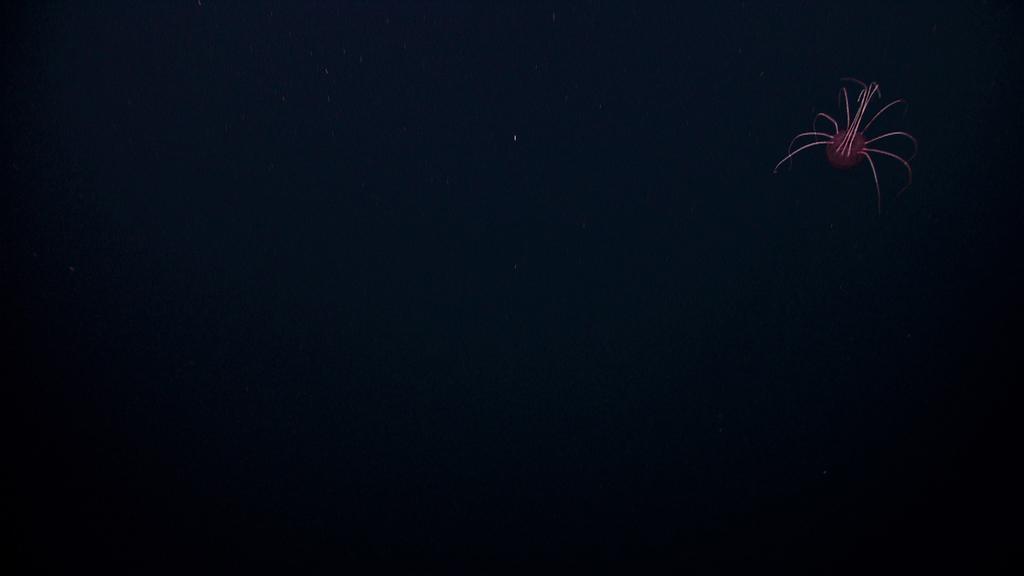Please provide a concise description of this image. In this image, on the right side, we can see a light. In the background, we can see black color. 